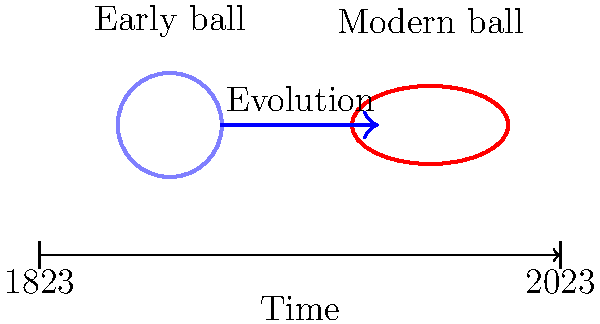How has the evolution of the rugby ball design, as illustrated in the timeline, primarily influenced the game's aerial tactics and overall gameplay? To answer this question, let's analyze the evolution of the rugby ball design and its effects on gameplay:

1. Early design (1823):
   - The ball was more spherical, similar to a soccer ball.
   - This shape made it easier to kick and dribble along the ground.
   - Passing was less accurate due to the ball's roundness.

2. Modern design (2023):
   - The ball has become more elongated and prolate spheroid in shape.
   - This design allows for:
     a) More accurate passing, as the pointed ends provide better grip and control.
     b) Improved spiral trajectory when thrown, increasing passing distance.
     c) Unpredictable bounces, adding an element of chance to the game.

3. Effects on gameplay:
   - Aerial tactics:
     a) The modern ball's shape enables longer, more precise passing.
     b) Kicking for territory has become more strategic due to the ball's flight characteristics.
   - Ball handling:
     a) Players can now grip the ball more securely, leading to fewer fumbles.
     b) The elongated shape allows for one-handed catches and offloads.
   - Strategic diversity:
     a) Teams can employ more complex passing plays due to increased accuracy.
     b) The kick-and-chase tactic has become more prevalent and effective.

4. Overall impact:
   - The game has evolved from a primarily ground-based, dribbling sport to one that incorporates more aerial play and strategic kicking.
   - This has led to a more dynamic and fast-paced game, with a greater emphasis on skill and strategy in both attacking and defensive play.

The evolution of the rugby ball design has thus significantly influenced the sport's tactics, particularly in terms of passing accuracy, kicking strategies, and aerial play.
Answer: Improved passing accuracy and aerial tactics 